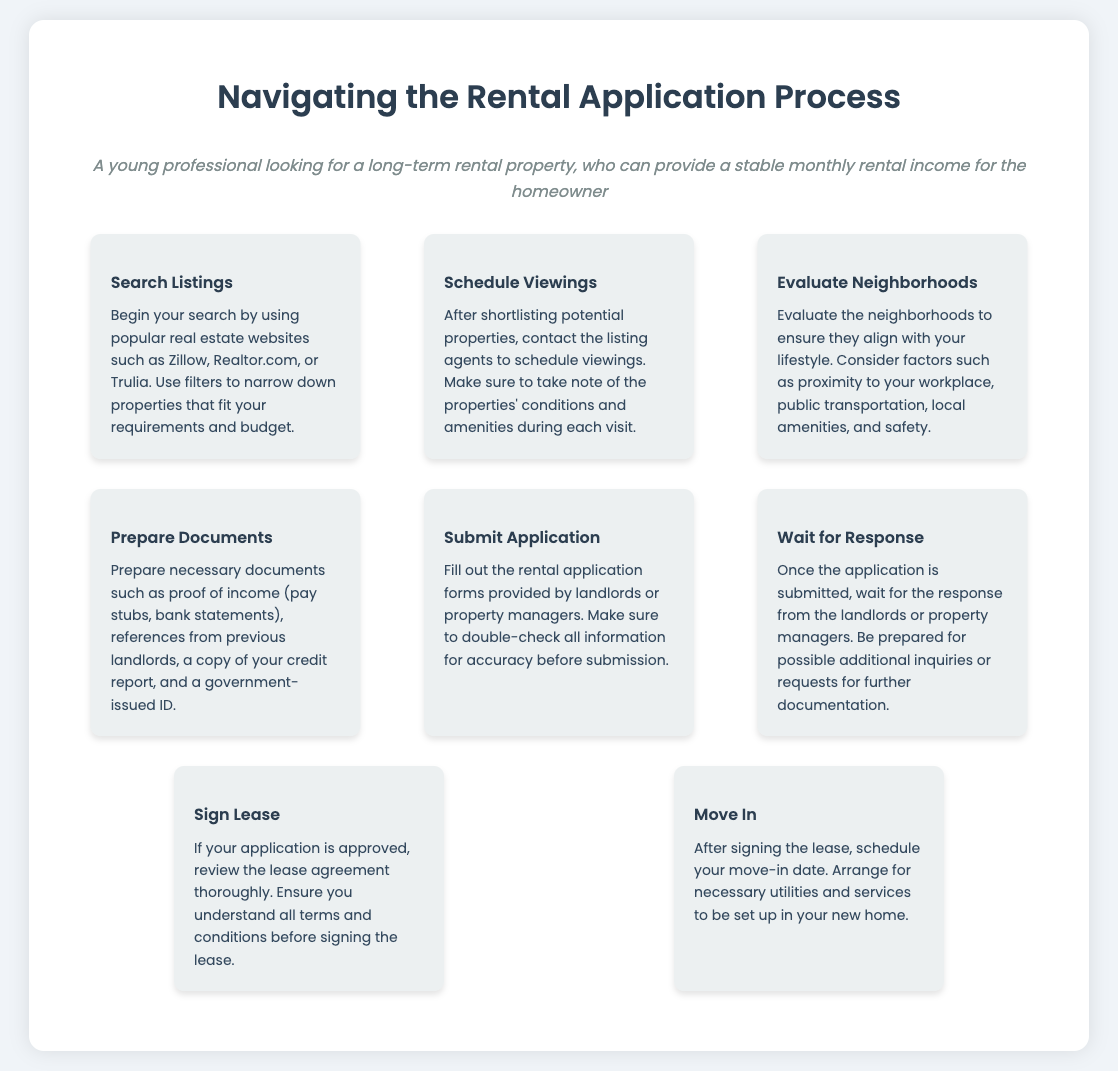what is the first step in the process? The first step listed in the process is searching for listings.
Answer: Search Listings how many steps are there in the rental application process? The document outlines a total of eight steps in the rental application process.
Answer: Eight what document is needed to prepare before submitting an application? The document states that references from previous landlords are needed before submitting an application.
Answer: References from previous landlords what action follows signing the lease? The next action after signing the lease is to move in.
Answer: Move In which step involves evaluating neighborhoods? The step that involves evaluating neighborhoods is titled "Evaluate Neighborhoods."
Answer: Evaluate Neighborhoods what is the main purpose of the "Wait for Response" step? This step is to anticipate the response from landlords or property managers after application submission.
Answer: Response anticipation which icon represents the "Submit Application" step? The icon that represents the "Submit Application" step is a paper plane.
Answer: Paper plane what should be reviewed thoroughly before signing? The lease agreement should be reviewed thoroughly before signing.
Answer: Lease agreement 